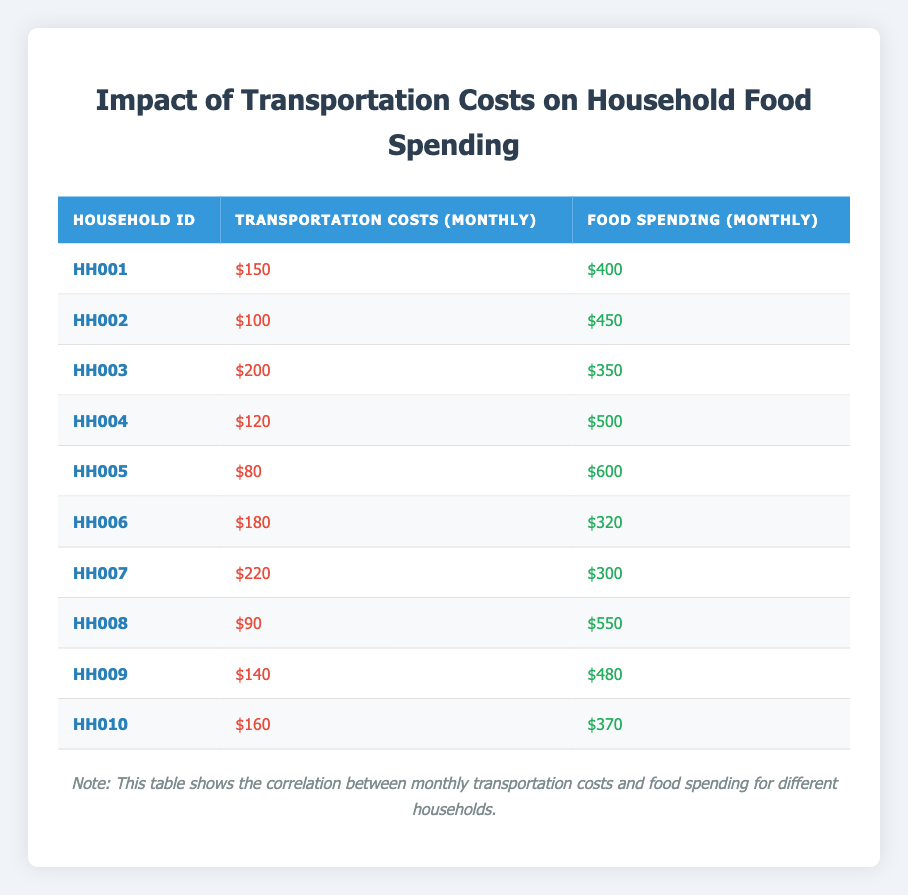What is the highest transportation cost among the households? Reviewing the transportation costs from the table, the costs listed are $150, $100, $200, $120, $80, $180, $220, $90, $140, and $160. The highest value among these is $220.
Answer: $220 What is the food spending for Household HH005? Looking at the table, for Household HH005, the food spending listed is $600.
Answer: $600 Is there a household with transportation costs of $90? By checking the table, I can see that Household HH008 has transportation costs of $90. Thus, the answer is yes.
Answer: Yes What is the average food spending for all households? To find the average, I sum the food spending amounts: (400 + 450 + 350 + 500 + 600 + 320 + 300 + 550 + 480 + 370) = 3970. Then, I divide by the number of households, which is 10. Therefore, the average food spending is 3970 / 10 = 397.
Answer: 397 For which household is food spending the lowest, and how much is it? Reviewing the food spending amounts, the values are $400, $450, $350, $500, $600, $320, $300, $550, $480, and $370. The lowest amount is $300, which belongs to Household HH007.
Answer: Household HH007, $300 How many households have transportation costs below $100? The transportation costs listed are $150, $100, $200, $120, $80, $180, $220, $90, $140, and $160. Only Household HH005 with $80 and Household HH008 with $90 fall below $100. Therefore, there are 2 households.
Answer: 2 What is the difference in food spending between the highest and lowest food spending households? Household HH005 has the highest food spending at $600 and Household HH007 has the lowest at $300. The difference is $600 - $300 = $300.
Answer: $300 Which household has the highest food spending, and what is the transportation cost for that household? Household HH005 has the highest food spending of $600. For Household HH005, the transportation cost is $80, according to the table.
Answer: Household HH005, $80 If a household spends $150 on transportation, how much do they typically spend on food? Looking at the table, the household with $150 in transportation costs is Household HH001, which spends $400 on food.
Answer: $400 